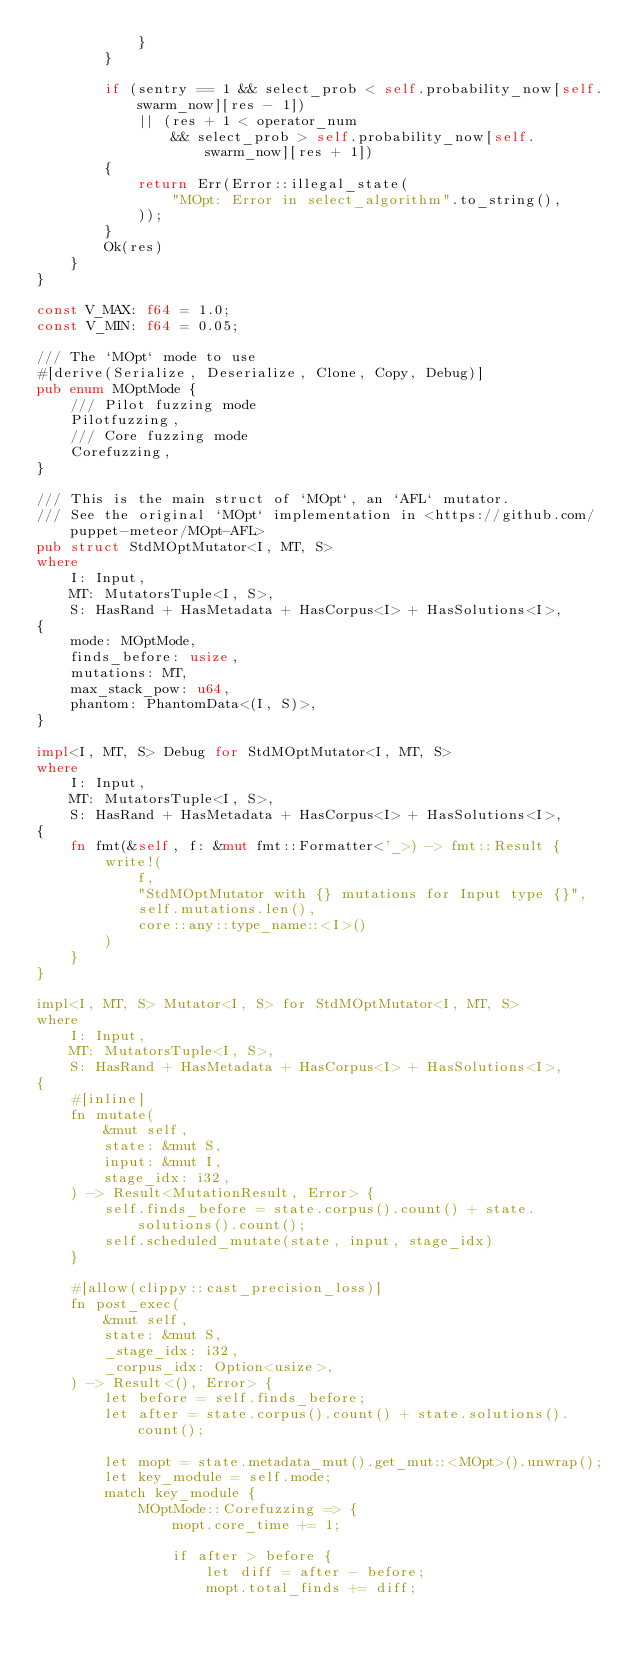<code> <loc_0><loc_0><loc_500><loc_500><_Rust_>            }
        }

        if (sentry == 1 && select_prob < self.probability_now[self.swarm_now][res - 1])
            || (res + 1 < operator_num
                && select_prob > self.probability_now[self.swarm_now][res + 1])
        {
            return Err(Error::illegal_state(
                "MOpt: Error in select_algorithm".to_string(),
            ));
        }
        Ok(res)
    }
}

const V_MAX: f64 = 1.0;
const V_MIN: f64 = 0.05;

/// The `MOpt` mode to use
#[derive(Serialize, Deserialize, Clone, Copy, Debug)]
pub enum MOptMode {
    /// Pilot fuzzing mode
    Pilotfuzzing,
    /// Core fuzzing mode
    Corefuzzing,
}

/// This is the main struct of `MOpt`, an `AFL` mutator.
/// See the original `MOpt` implementation in <https://github.com/puppet-meteor/MOpt-AFL>
pub struct StdMOptMutator<I, MT, S>
where
    I: Input,
    MT: MutatorsTuple<I, S>,
    S: HasRand + HasMetadata + HasCorpus<I> + HasSolutions<I>,
{
    mode: MOptMode,
    finds_before: usize,
    mutations: MT,
    max_stack_pow: u64,
    phantom: PhantomData<(I, S)>,
}

impl<I, MT, S> Debug for StdMOptMutator<I, MT, S>
where
    I: Input,
    MT: MutatorsTuple<I, S>,
    S: HasRand + HasMetadata + HasCorpus<I> + HasSolutions<I>,
{
    fn fmt(&self, f: &mut fmt::Formatter<'_>) -> fmt::Result {
        write!(
            f,
            "StdMOptMutator with {} mutations for Input type {}",
            self.mutations.len(),
            core::any::type_name::<I>()
        )
    }
}

impl<I, MT, S> Mutator<I, S> for StdMOptMutator<I, MT, S>
where
    I: Input,
    MT: MutatorsTuple<I, S>,
    S: HasRand + HasMetadata + HasCorpus<I> + HasSolutions<I>,
{
    #[inline]
    fn mutate(
        &mut self,
        state: &mut S,
        input: &mut I,
        stage_idx: i32,
    ) -> Result<MutationResult, Error> {
        self.finds_before = state.corpus().count() + state.solutions().count();
        self.scheduled_mutate(state, input, stage_idx)
    }

    #[allow(clippy::cast_precision_loss)]
    fn post_exec(
        &mut self,
        state: &mut S,
        _stage_idx: i32,
        _corpus_idx: Option<usize>,
    ) -> Result<(), Error> {
        let before = self.finds_before;
        let after = state.corpus().count() + state.solutions().count();

        let mopt = state.metadata_mut().get_mut::<MOpt>().unwrap();
        let key_module = self.mode;
        match key_module {
            MOptMode::Corefuzzing => {
                mopt.core_time += 1;

                if after > before {
                    let diff = after - before;
                    mopt.total_finds += diff;</code> 